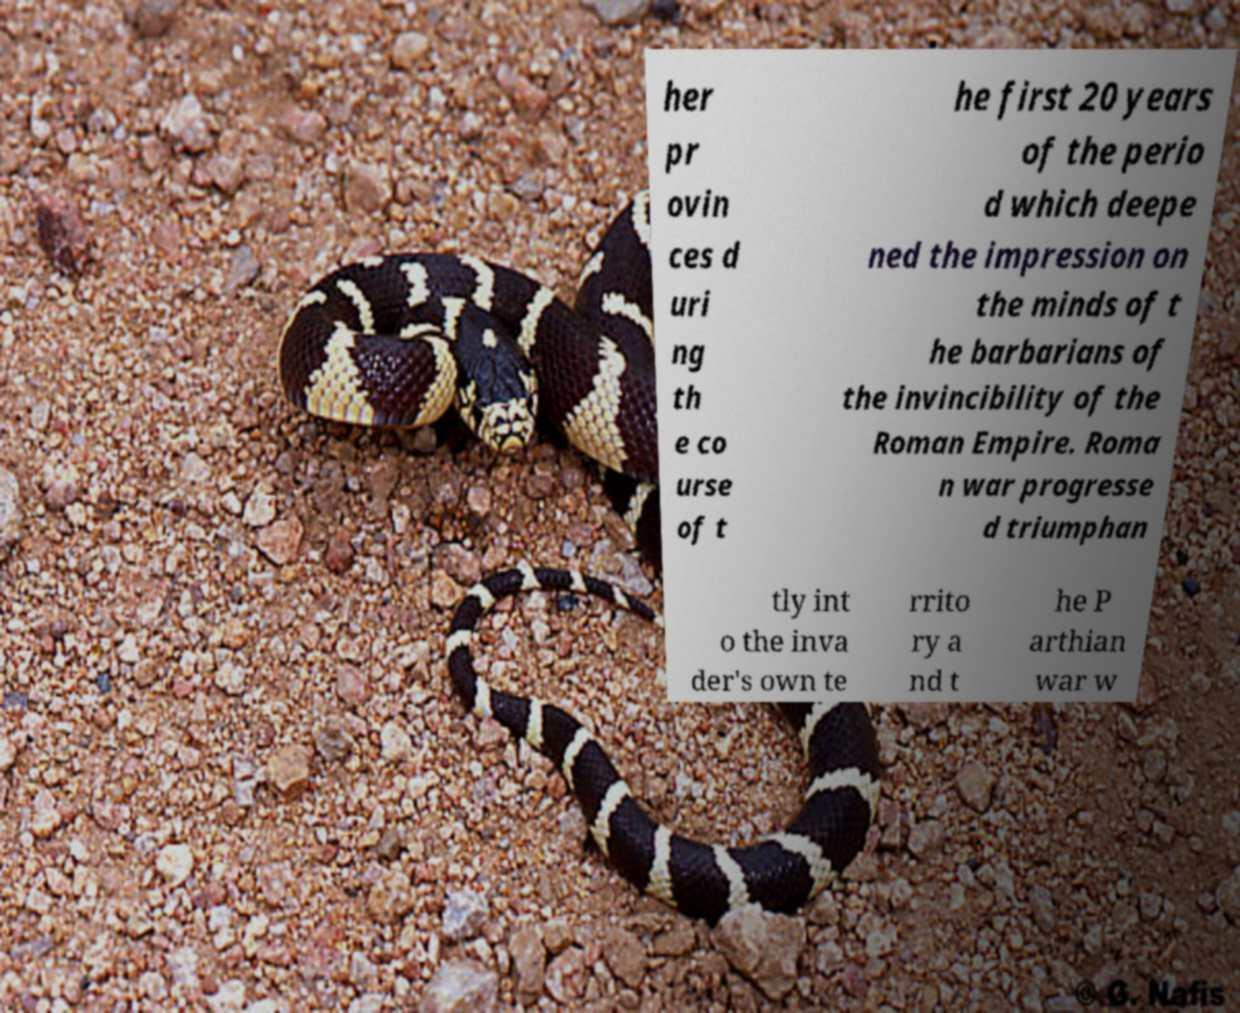For documentation purposes, I need the text within this image transcribed. Could you provide that? her pr ovin ces d uri ng th e co urse of t he first 20 years of the perio d which deepe ned the impression on the minds of t he barbarians of the invincibility of the Roman Empire. Roma n war progresse d triumphan tly int o the inva der's own te rrito ry a nd t he P arthian war w 